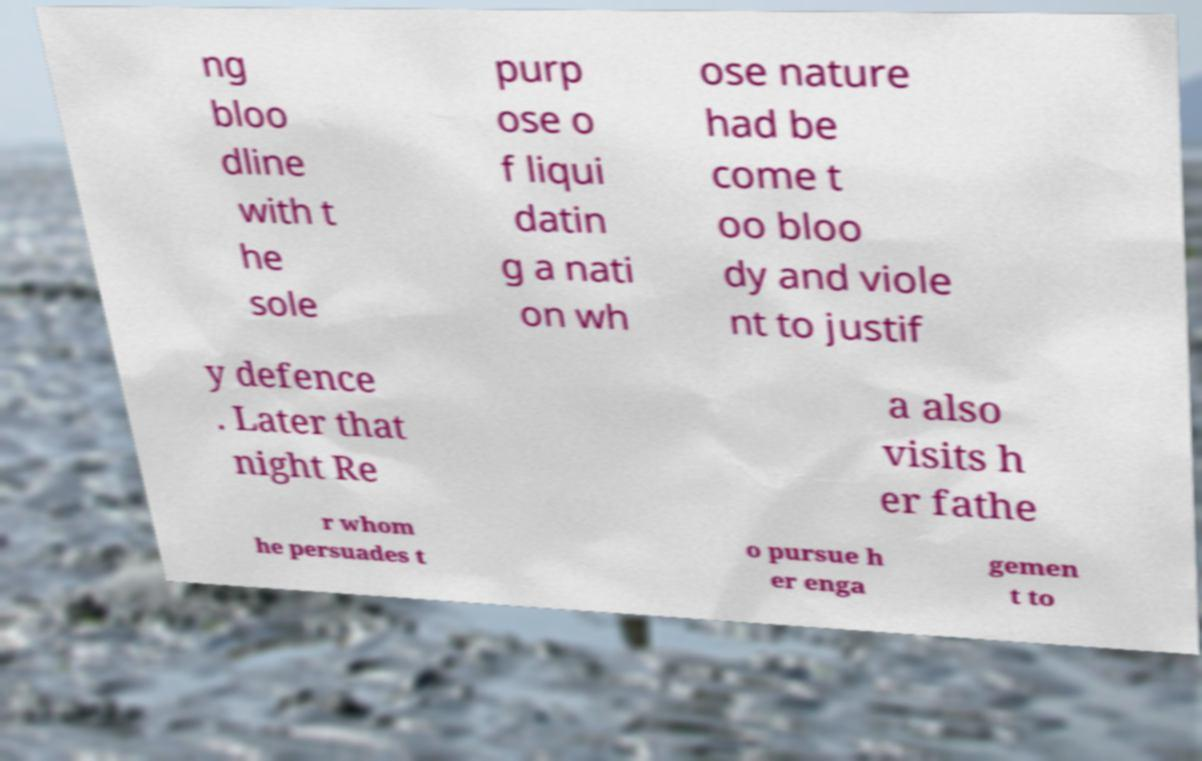For documentation purposes, I need the text within this image transcribed. Could you provide that? ng bloo dline with t he sole purp ose o f liqui datin g a nati on wh ose nature had be come t oo bloo dy and viole nt to justif y defence . Later that night Re a also visits h er fathe r whom he persuades t o pursue h er enga gemen t to 